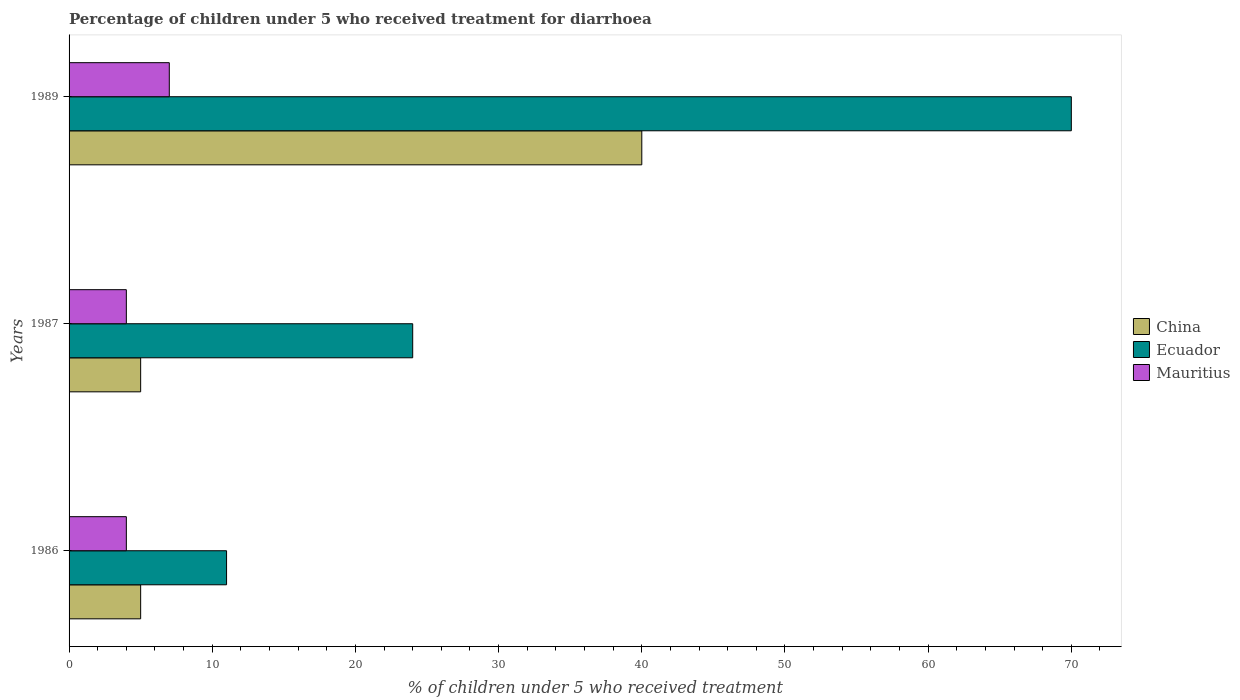How many different coloured bars are there?
Keep it short and to the point. 3. How many bars are there on the 3rd tick from the bottom?
Make the answer very short. 3. Across all years, what is the maximum percentage of children who received treatment for diarrhoea  in China?
Offer a terse response. 40. In which year was the percentage of children who received treatment for diarrhoea  in Ecuador maximum?
Keep it short and to the point. 1989. In which year was the percentage of children who received treatment for diarrhoea  in Ecuador minimum?
Your response must be concise. 1986. What is the total percentage of children who received treatment for diarrhoea  in China in the graph?
Your answer should be very brief. 50. What is the difference between the percentage of children who received treatment for diarrhoea  in Mauritius in 1987 and that in 1989?
Give a very brief answer. -3. What is the difference between the percentage of children who received treatment for diarrhoea  in Mauritius in 1987 and the percentage of children who received treatment for diarrhoea  in China in 1986?
Ensure brevity in your answer.  -1. In the year 1989, what is the difference between the percentage of children who received treatment for diarrhoea  in Ecuador and percentage of children who received treatment for diarrhoea  in China?
Ensure brevity in your answer.  30. In how many years, is the percentage of children who received treatment for diarrhoea  in Ecuador greater than 20 %?
Your answer should be very brief. 2. What is the ratio of the percentage of children who received treatment for diarrhoea  in Ecuador in 1986 to that in 1989?
Ensure brevity in your answer.  0.16. Is the difference between the percentage of children who received treatment for diarrhoea  in Ecuador in 1986 and 1989 greater than the difference between the percentage of children who received treatment for diarrhoea  in China in 1986 and 1989?
Provide a succinct answer. No. What is the difference between the highest and the lowest percentage of children who received treatment for diarrhoea  in China?
Make the answer very short. 35. Is the sum of the percentage of children who received treatment for diarrhoea  in Mauritius in 1986 and 1989 greater than the maximum percentage of children who received treatment for diarrhoea  in China across all years?
Your response must be concise. No. What does the 1st bar from the top in 1986 represents?
Make the answer very short. Mauritius. What does the 2nd bar from the bottom in 1986 represents?
Give a very brief answer. Ecuador. Is it the case that in every year, the sum of the percentage of children who received treatment for diarrhoea  in Mauritius and percentage of children who received treatment for diarrhoea  in China is greater than the percentage of children who received treatment for diarrhoea  in Ecuador?
Offer a terse response. No. How many bars are there?
Your response must be concise. 9. What is the difference between two consecutive major ticks on the X-axis?
Give a very brief answer. 10. Are the values on the major ticks of X-axis written in scientific E-notation?
Offer a terse response. No. Does the graph contain grids?
Your answer should be compact. No. Where does the legend appear in the graph?
Ensure brevity in your answer.  Center right. How are the legend labels stacked?
Offer a terse response. Vertical. What is the title of the graph?
Offer a terse response. Percentage of children under 5 who received treatment for diarrhoea. What is the label or title of the X-axis?
Keep it short and to the point. % of children under 5 who received treatment. What is the % of children under 5 who received treatment in China in 1986?
Provide a succinct answer. 5. What is the % of children under 5 who received treatment of China in 1987?
Offer a terse response. 5. What is the % of children under 5 who received treatment in Ecuador in 1989?
Provide a short and direct response. 70. What is the % of children under 5 who received treatment of Mauritius in 1989?
Your response must be concise. 7. Across all years, what is the maximum % of children under 5 who received treatment of Ecuador?
Make the answer very short. 70. Across all years, what is the maximum % of children under 5 who received treatment of Mauritius?
Your answer should be very brief. 7. Across all years, what is the minimum % of children under 5 who received treatment in China?
Provide a succinct answer. 5. What is the total % of children under 5 who received treatment in China in the graph?
Provide a short and direct response. 50. What is the total % of children under 5 who received treatment in Ecuador in the graph?
Ensure brevity in your answer.  105. What is the difference between the % of children under 5 who received treatment in Ecuador in 1986 and that in 1987?
Ensure brevity in your answer.  -13. What is the difference between the % of children under 5 who received treatment of China in 1986 and that in 1989?
Your answer should be very brief. -35. What is the difference between the % of children under 5 who received treatment in Ecuador in 1986 and that in 1989?
Give a very brief answer. -59. What is the difference between the % of children under 5 who received treatment in Mauritius in 1986 and that in 1989?
Keep it short and to the point. -3. What is the difference between the % of children under 5 who received treatment of China in 1987 and that in 1989?
Provide a short and direct response. -35. What is the difference between the % of children under 5 who received treatment in Ecuador in 1987 and that in 1989?
Offer a very short reply. -46. What is the difference between the % of children under 5 who received treatment of Mauritius in 1987 and that in 1989?
Your answer should be compact. -3. What is the difference between the % of children under 5 who received treatment in China in 1986 and the % of children under 5 who received treatment in Ecuador in 1987?
Offer a terse response. -19. What is the difference between the % of children under 5 who received treatment of China in 1986 and the % of children under 5 who received treatment of Mauritius in 1987?
Your answer should be compact. 1. What is the difference between the % of children under 5 who received treatment in Ecuador in 1986 and the % of children under 5 who received treatment in Mauritius in 1987?
Offer a terse response. 7. What is the difference between the % of children under 5 who received treatment in China in 1986 and the % of children under 5 who received treatment in Ecuador in 1989?
Offer a very short reply. -65. What is the difference between the % of children under 5 who received treatment in China in 1986 and the % of children under 5 who received treatment in Mauritius in 1989?
Provide a short and direct response. -2. What is the difference between the % of children under 5 who received treatment of China in 1987 and the % of children under 5 who received treatment of Ecuador in 1989?
Keep it short and to the point. -65. What is the average % of children under 5 who received treatment of China per year?
Your response must be concise. 16.67. What is the average % of children under 5 who received treatment in Ecuador per year?
Offer a terse response. 35. What is the average % of children under 5 who received treatment of Mauritius per year?
Offer a terse response. 5. In the year 1986, what is the difference between the % of children under 5 who received treatment in China and % of children under 5 who received treatment in Ecuador?
Give a very brief answer. -6. In the year 1986, what is the difference between the % of children under 5 who received treatment in Ecuador and % of children under 5 who received treatment in Mauritius?
Provide a succinct answer. 7. In the year 1987, what is the difference between the % of children under 5 who received treatment in China and % of children under 5 who received treatment in Ecuador?
Keep it short and to the point. -19. In the year 1987, what is the difference between the % of children under 5 who received treatment of China and % of children under 5 who received treatment of Mauritius?
Your answer should be compact. 1. In the year 1987, what is the difference between the % of children under 5 who received treatment of Ecuador and % of children under 5 who received treatment of Mauritius?
Provide a succinct answer. 20. What is the ratio of the % of children under 5 who received treatment of China in 1986 to that in 1987?
Ensure brevity in your answer.  1. What is the ratio of the % of children under 5 who received treatment of Ecuador in 1986 to that in 1987?
Your answer should be compact. 0.46. What is the ratio of the % of children under 5 who received treatment of Mauritius in 1986 to that in 1987?
Your answer should be compact. 1. What is the ratio of the % of children under 5 who received treatment of Ecuador in 1986 to that in 1989?
Your response must be concise. 0.16. What is the ratio of the % of children under 5 who received treatment in Ecuador in 1987 to that in 1989?
Give a very brief answer. 0.34. What is the ratio of the % of children under 5 who received treatment in Mauritius in 1987 to that in 1989?
Give a very brief answer. 0.57. What is the difference between the highest and the second highest % of children under 5 who received treatment in Mauritius?
Provide a succinct answer. 3. What is the difference between the highest and the lowest % of children under 5 who received treatment of China?
Offer a terse response. 35. What is the difference between the highest and the lowest % of children under 5 who received treatment in Mauritius?
Your response must be concise. 3. 